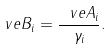<formula> <loc_0><loc_0><loc_500><loc_500>\ v e { B } _ { i } = \frac { \ v e { A } _ { i } } { \gamma _ { i } } .</formula> 